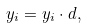<formula> <loc_0><loc_0><loc_500><loc_500>y _ { i } = { y } _ { i } \cdot { d } ,</formula> 